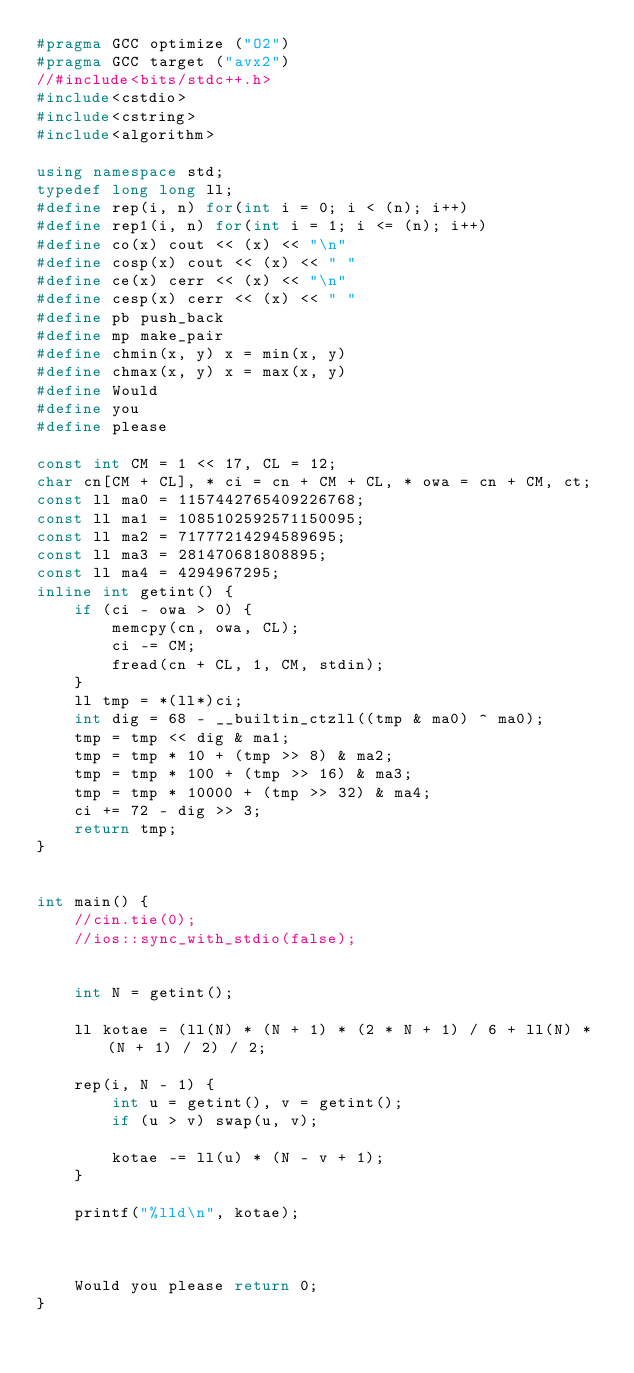<code> <loc_0><loc_0><loc_500><loc_500><_C++_>#pragma GCC optimize ("O2")
#pragma GCC target ("avx2")
//#include<bits/stdc++.h>
#include<cstdio>
#include<cstring>
#include<algorithm>

using namespace std;
typedef long long ll;
#define rep(i, n) for(int i = 0; i < (n); i++)
#define rep1(i, n) for(int i = 1; i <= (n); i++)
#define co(x) cout << (x) << "\n"
#define cosp(x) cout << (x) << " "
#define ce(x) cerr << (x) << "\n"
#define cesp(x) cerr << (x) << " "
#define pb push_back
#define mp make_pair
#define chmin(x, y) x = min(x, y)
#define chmax(x, y) x = max(x, y)
#define Would
#define you
#define please

const int CM = 1 << 17, CL = 12;
char cn[CM + CL], * ci = cn + CM + CL, * owa = cn + CM, ct;
const ll ma0 = 1157442765409226768;
const ll ma1 = 1085102592571150095;
const ll ma2 = 71777214294589695;
const ll ma3 = 281470681808895;
const ll ma4 = 4294967295;
inline int getint() {
	if (ci - owa > 0) {
		memcpy(cn, owa, CL);
		ci -= CM;
		fread(cn + CL, 1, CM, stdin);
	}
	ll tmp = *(ll*)ci;
	int dig = 68 - __builtin_ctzll((tmp & ma0) ^ ma0);
	tmp = tmp << dig & ma1;
	tmp = tmp * 10 + (tmp >> 8) & ma2;
	tmp = tmp * 100 + (tmp >> 16) & ma3;
	tmp = tmp * 10000 + (tmp >> 32) & ma4;
	ci += 72 - dig >> 3;
	return tmp;
}


int main() {
	//cin.tie(0);
	//ios::sync_with_stdio(false);


	int N = getint();

	ll kotae = (ll(N) * (N + 1) * (2 * N + 1) / 6 + ll(N) * (N + 1) / 2) / 2;

	rep(i, N - 1) {
		int u = getint(), v = getint();
		if (u > v) swap(u, v);

		kotae -= ll(u) * (N - v + 1);
	}

	printf("%lld\n", kotae);



	Would you please return 0;
}</code> 